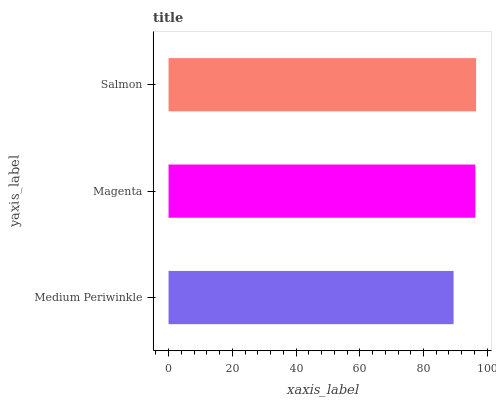Is Medium Periwinkle the minimum?
Answer yes or no. Yes. Is Salmon the maximum?
Answer yes or no. Yes. Is Magenta the minimum?
Answer yes or no. No. Is Magenta the maximum?
Answer yes or no. No. Is Magenta greater than Medium Periwinkle?
Answer yes or no. Yes. Is Medium Periwinkle less than Magenta?
Answer yes or no. Yes. Is Medium Periwinkle greater than Magenta?
Answer yes or no. No. Is Magenta less than Medium Periwinkle?
Answer yes or no. No. Is Magenta the high median?
Answer yes or no. Yes. Is Magenta the low median?
Answer yes or no. Yes. Is Medium Periwinkle the high median?
Answer yes or no. No. Is Salmon the low median?
Answer yes or no. No. 